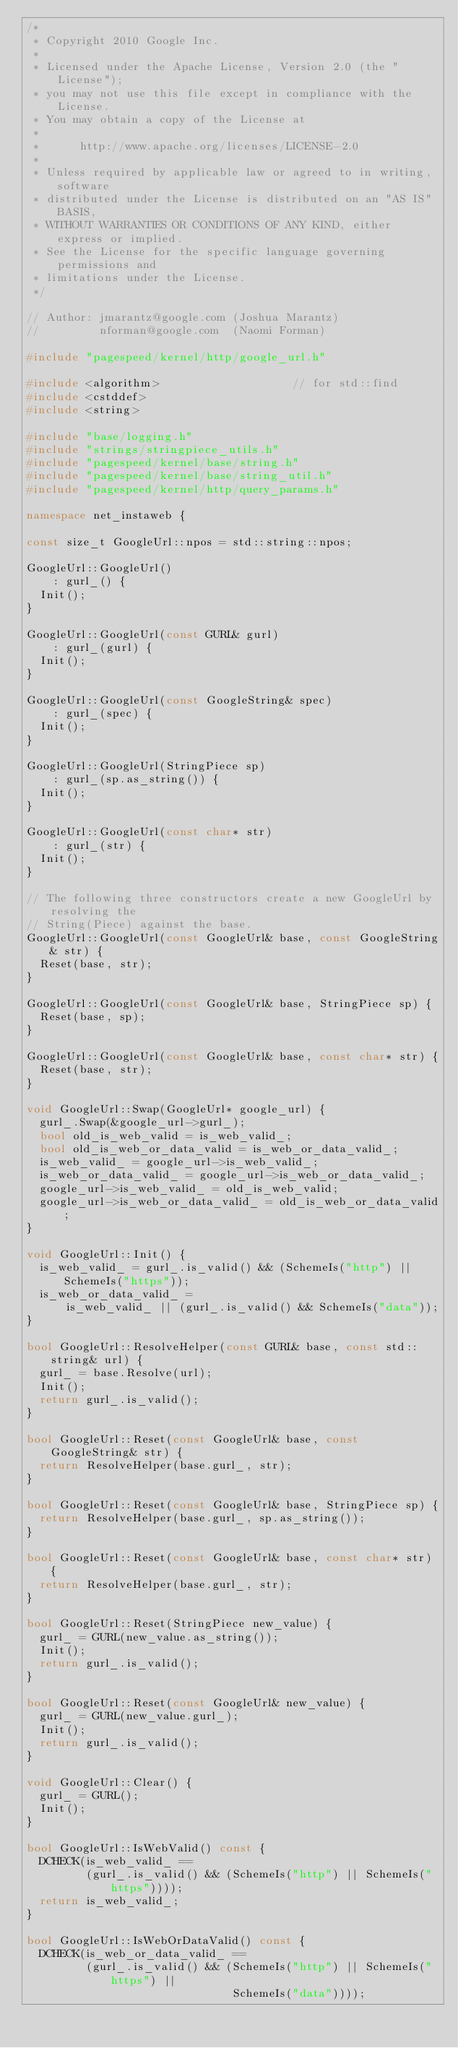<code> <loc_0><loc_0><loc_500><loc_500><_C++_>/*
 * Copyright 2010 Google Inc.
 *
 * Licensed under the Apache License, Version 2.0 (the "License");
 * you may not use this file except in compliance with the License.
 * You may obtain a copy of the License at
 *
 *      http://www.apache.org/licenses/LICENSE-2.0
 *
 * Unless required by applicable law or agreed to in writing, software
 * distributed under the License is distributed on an "AS IS" BASIS,
 * WITHOUT WARRANTIES OR CONDITIONS OF ANY KIND, either express or implied.
 * See the License for the specific language governing permissions and
 * limitations under the License.
 */

// Author: jmarantz@google.com (Joshua Marantz)
//         nforman@google.com  (Naomi Forman)

#include "pagespeed/kernel/http/google_url.h"

#include <algorithm>                    // for std::find
#include <cstddef>
#include <string>

#include "base/logging.h"
#include "strings/stringpiece_utils.h"
#include "pagespeed/kernel/base/string.h"
#include "pagespeed/kernel/base/string_util.h"
#include "pagespeed/kernel/http/query_params.h"

namespace net_instaweb {

const size_t GoogleUrl::npos = std::string::npos;

GoogleUrl::GoogleUrl()
    : gurl_() {
  Init();
}

GoogleUrl::GoogleUrl(const GURL& gurl)
    : gurl_(gurl) {
  Init();
}

GoogleUrl::GoogleUrl(const GoogleString& spec)
    : gurl_(spec) {
  Init();
}

GoogleUrl::GoogleUrl(StringPiece sp)
    : gurl_(sp.as_string()) {
  Init();
}

GoogleUrl::GoogleUrl(const char* str)
    : gurl_(str) {
  Init();
}

// The following three constructors create a new GoogleUrl by resolving the
// String(Piece) against the base.
GoogleUrl::GoogleUrl(const GoogleUrl& base, const GoogleString& str) {
  Reset(base, str);
}

GoogleUrl::GoogleUrl(const GoogleUrl& base, StringPiece sp) {
  Reset(base, sp);
}

GoogleUrl::GoogleUrl(const GoogleUrl& base, const char* str) {
  Reset(base, str);
}

void GoogleUrl::Swap(GoogleUrl* google_url) {
  gurl_.Swap(&google_url->gurl_);
  bool old_is_web_valid = is_web_valid_;
  bool old_is_web_or_data_valid = is_web_or_data_valid_;
  is_web_valid_ = google_url->is_web_valid_;
  is_web_or_data_valid_ = google_url->is_web_or_data_valid_;
  google_url->is_web_valid_ = old_is_web_valid;
  google_url->is_web_or_data_valid_ = old_is_web_or_data_valid;
}

void GoogleUrl::Init() {
  is_web_valid_ = gurl_.is_valid() && (SchemeIs("http") || SchemeIs("https"));
  is_web_or_data_valid_ =
      is_web_valid_ || (gurl_.is_valid() && SchemeIs("data"));
}

bool GoogleUrl::ResolveHelper(const GURL& base, const std::string& url) {
  gurl_ = base.Resolve(url);
  Init();
  return gurl_.is_valid();
}

bool GoogleUrl::Reset(const GoogleUrl& base, const GoogleString& str) {
  return ResolveHelper(base.gurl_, str);
}

bool GoogleUrl::Reset(const GoogleUrl& base, StringPiece sp) {
  return ResolveHelper(base.gurl_, sp.as_string());
}

bool GoogleUrl::Reset(const GoogleUrl& base, const char* str) {
  return ResolveHelper(base.gurl_, str);
}

bool GoogleUrl::Reset(StringPiece new_value) {
  gurl_ = GURL(new_value.as_string());
  Init();
  return gurl_.is_valid();
}

bool GoogleUrl::Reset(const GoogleUrl& new_value) {
  gurl_ = GURL(new_value.gurl_);
  Init();
  return gurl_.is_valid();
}

void GoogleUrl::Clear() {
  gurl_ = GURL();
  Init();
}

bool GoogleUrl::IsWebValid() const {
  DCHECK(is_web_valid_ ==
         (gurl_.is_valid() && (SchemeIs("http") || SchemeIs("https"))));
  return is_web_valid_;
}

bool GoogleUrl::IsWebOrDataValid() const {
  DCHECK(is_web_or_data_valid_ ==
         (gurl_.is_valid() && (SchemeIs("http") || SchemeIs("https") ||
                               SchemeIs("data"))));</code> 